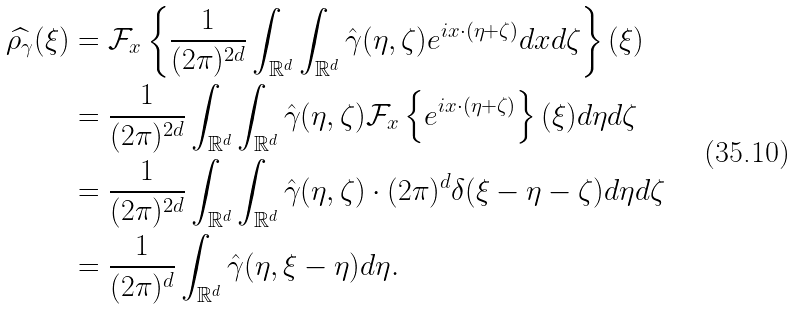<formula> <loc_0><loc_0><loc_500><loc_500>\widehat { \rho _ { \gamma } } ( \xi ) & = \mathcal { F } _ { x } \left \{ \frac { 1 } { ( 2 \pi ) ^ { 2 d } } \int _ { \mathbb { R } ^ { d } } \int _ { \mathbb { R } ^ { d } } \hat { \gamma } ( \eta , \zeta ) e ^ { i x \cdot ( \eta + \zeta ) } d x d \zeta \right \} ( \xi ) \\ & = \frac { 1 } { ( 2 \pi ) ^ { 2 d } } \int _ { \mathbb { R } ^ { d } } \int _ { \mathbb { R } ^ { d } } \hat { \gamma } ( \eta , \zeta ) \mathcal { F } _ { x } \left \{ e ^ { i x \cdot ( \eta + \zeta ) } \right \} ( \xi ) d \eta d \zeta \\ & = \frac { 1 } { ( 2 \pi ) ^ { 2 d } } \int _ { \mathbb { R } ^ { d } } \int _ { \mathbb { R } ^ { d } } \hat { \gamma } ( \eta , \zeta ) \cdot ( 2 \pi ) ^ { d } \delta ( \xi - \eta - \zeta ) d \eta d \zeta \\ & = \frac { 1 } { ( 2 \pi ) ^ { d } } \int _ { \mathbb { R } ^ { d } } \hat { \gamma } ( \eta , \xi - \eta ) d \eta .</formula> 